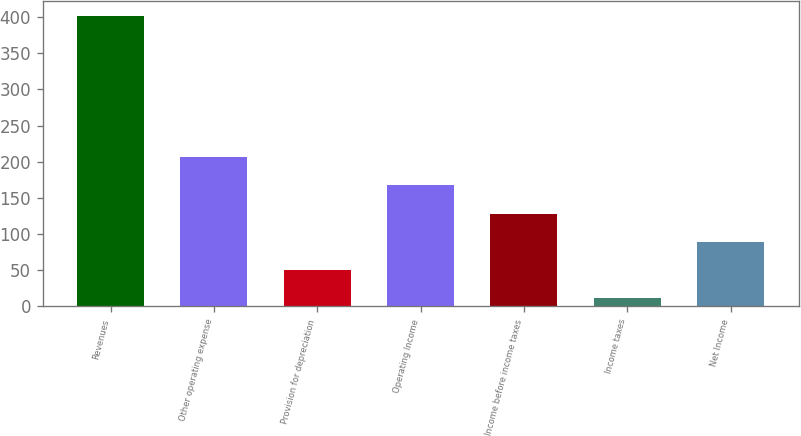<chart> <loc_0><loc_0><loc_500><loc_500><bar_chart><fcel>Revenues<fcel>Other operating expense<fcel>Provision for depreciation<fcel>Operating Income<fcel>Income before income taxes<fcel>Income taxes<fcel>Net Income<nl><fcel>402<fcel>206.5<fcel>50.1<fcel>167.4<fcel>128.3<fcel>11<fcel>89.2<nl></chart> 